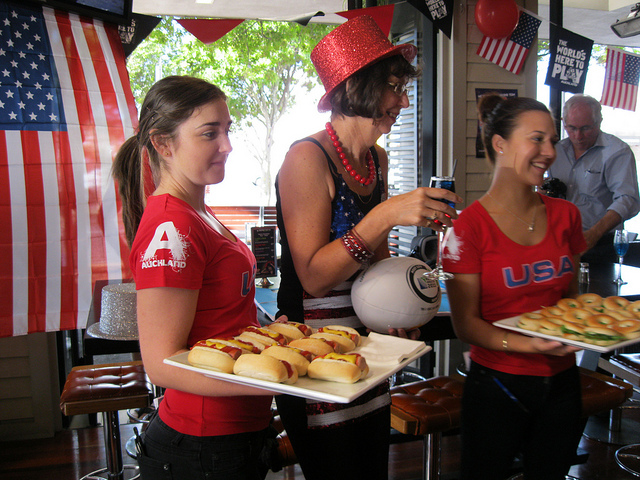Read all the text in this image. AUCHLAND USA PLAY WORLD'S TO HERE 